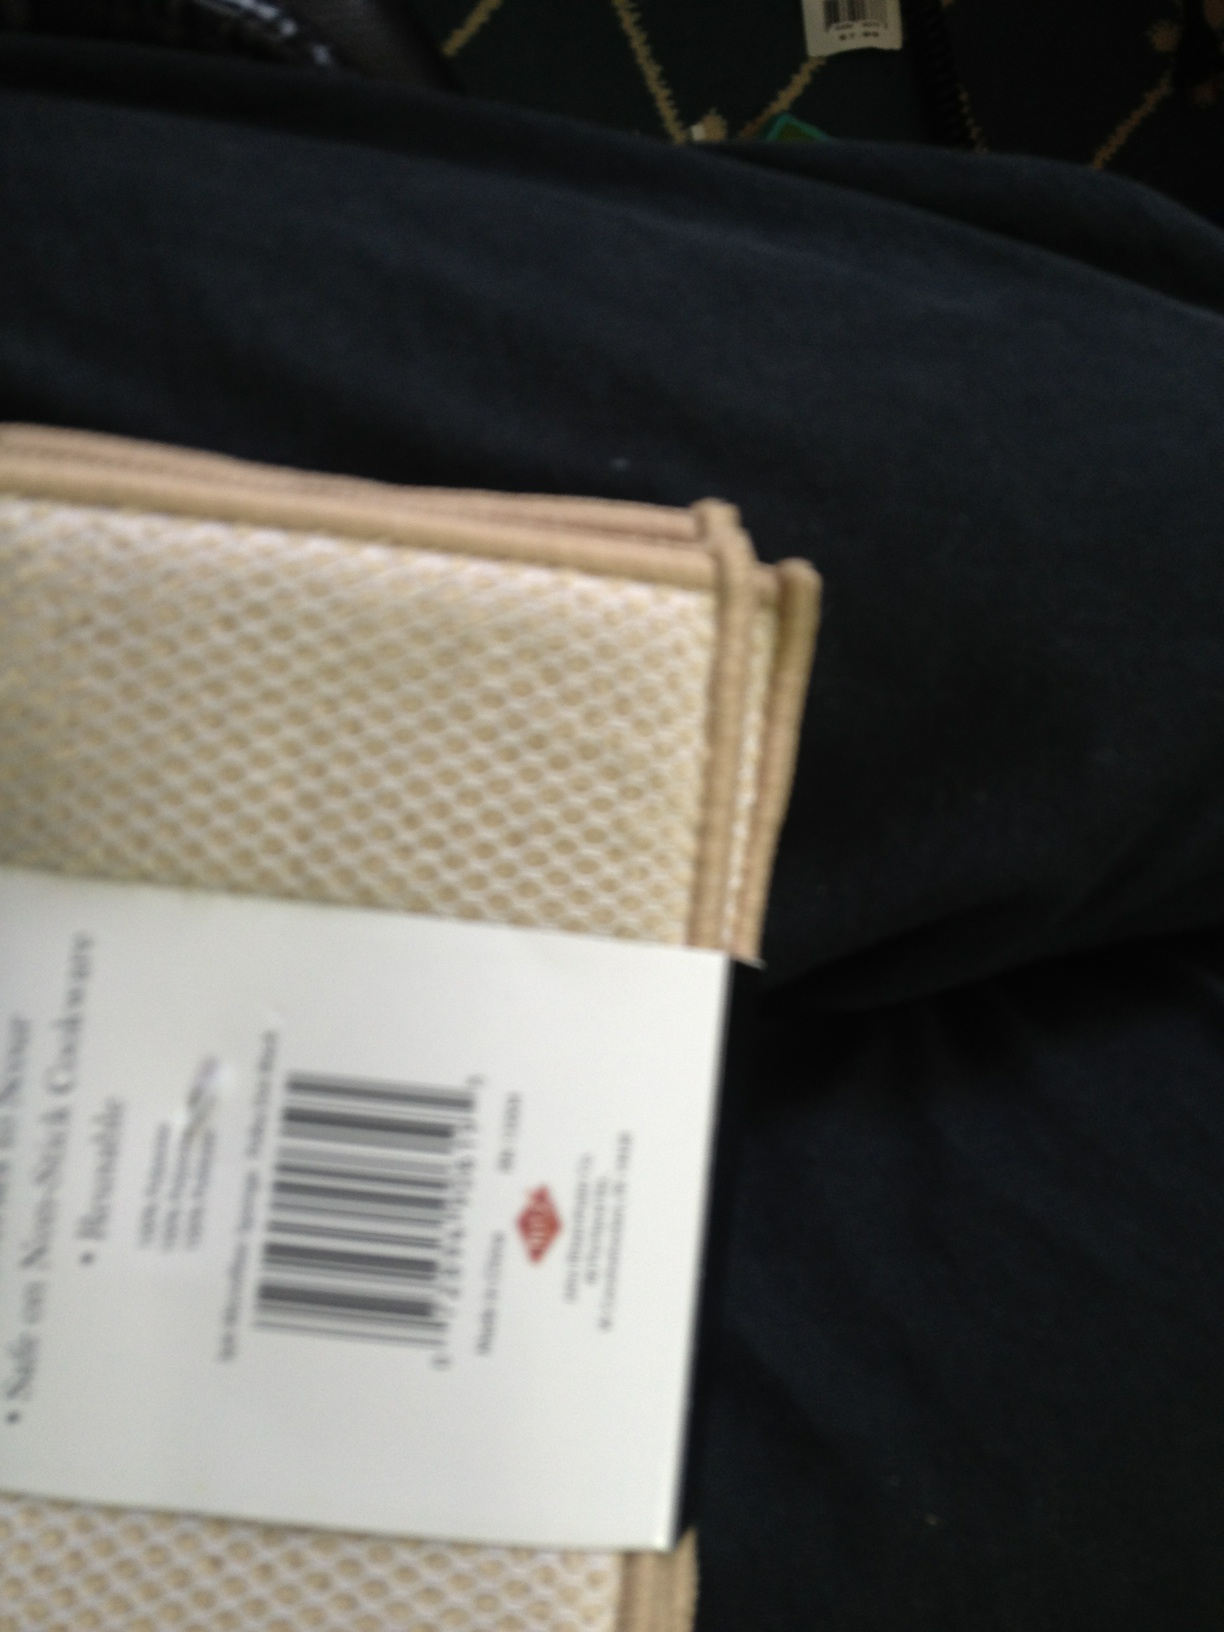What color are in these sponges? Unfortunately, it seems there has been a misunderstanding. The image does not depict sponges. Instead, it shows an item with a beige pattern, possibly a wallet or a holder of some sort, alongside a part of someone's leg wearing black pants and a surface that could be the inside of a vehicle or a couch with a green pattern. 